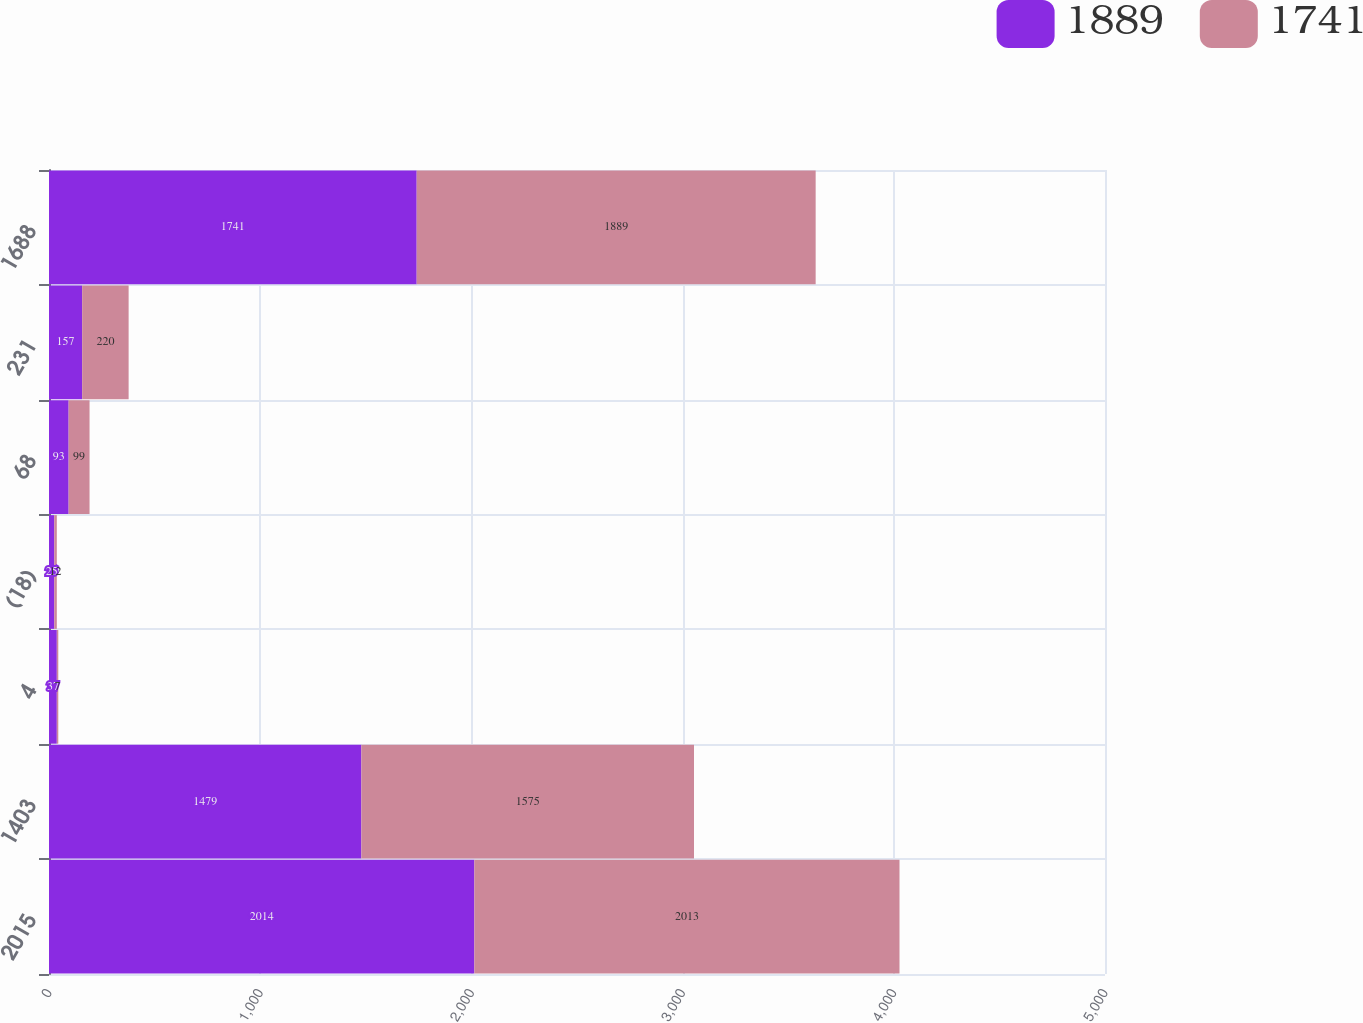Convert chart. <chart><loc_0><loc_0><loc_500><loc_500><stacked_bar_chart><ecel><fcel>2015<fcel>1403<fcel>4<fcel>(18)<fcel>68<fcel>231<fcel>1688<nl><fcel>1889<fcel>2014<fcel>1479<fcel>37<fcel>25<fcel>93<fcel>157<fcel>1741<nl><fcel>1741<fcel>2013<fcel>1575<fcel>7<fcel>12<fcel>99<fcel>220<fcel>1889<nl></chart> 